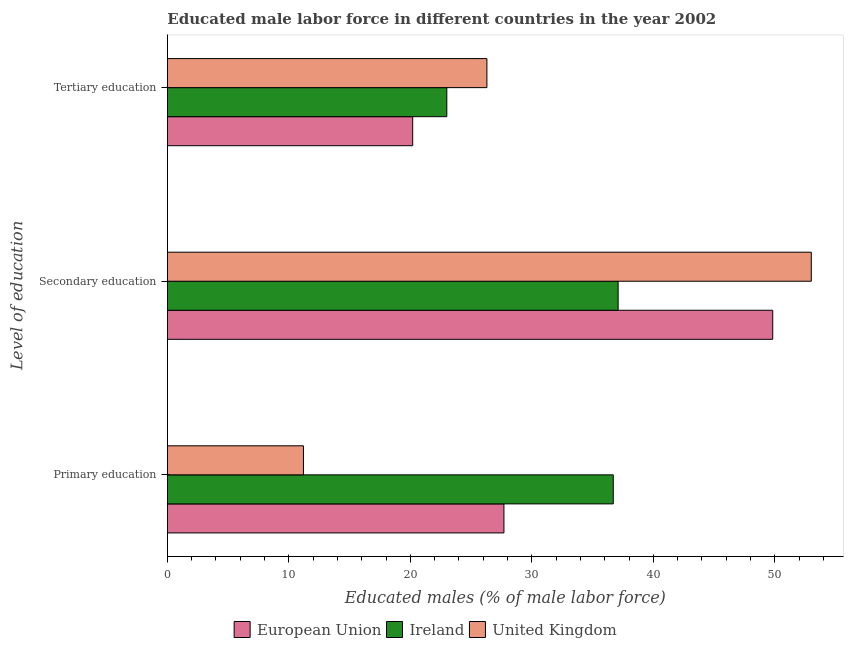Are the number of bars per tick equal to the number of legend labels?
Your response must be concise. Yes. How many bars are there on the 2nd tick from the top?
Your answer should be very brief. 3. What is the label of the 3rd group of bars from the top?
Give a very brief answer. Primary education. What is the percentage of male labor force who received tertiary education in Ireland?
Offer a terse response. 23. Across all countries, what is the maximum percentage of male labor force who received primary education?
Give a very brief answer. 36.7. Across all countries, what is the minimum percentage of male labor force who received primary education?
Provide a short and direct response. 11.2. In which country was the percentage of male labor force who received tertiary education maximum?
Give a very brief answer. United Kingdom. In which country was the percentage of male labor force who received secondary education minimum?
Offer a very short reply. Ireland. What is the total percentage of male labor force who received secondary education in the graph?
Make the answer very short. 139.93. What is the difference between the percentage of male labor force who received secondary education in Ireland and that in United Kingdom?
Make the answer very short. -15.9. What is the difference between the percentage of male labor force who received secondary education in European Union and the percentage of male labor force who received primary education in Ireland?
Offer a terse response. 13.13. What is the average percentage of male labor force who received secondary education per country?
Give a very brief answer. 46.64. What is the difference between the percentage of male labor force who received secondary education and percentage of male labor force who received primary education in United Kingdom?
Your response must be concise. 41.8. What is the ratio of the percentage of male labor force who received secondary education in European Union to that in Ireland?
Your response must be concise. 1.34. Is the percentage of male labor force who received primary education in Ireland less than that in European Union?
Make the answer very short. No. What is the difference between the highest and the second highest percentage of male labor force who received tertiary education?
Your response must be concise. 3.3. What is the difference between the highest and the lowest percentage of male labor force who received secondary education?
Provide a short and direct response. 15.9. Is the sum of the percentage of male labor force who received tertiary education in United Kingdom and Ireland greater than the maximum percentage of male labor force who received secondary education across all countries?
Your answer should be compact. No. What does the 1st bar from the top in Primary education represents?
Ensure brevity in your answer.  United Kingdom. How many countries are there in the graph?
Give a very brief answer. 3. Are the values on the major ticks of X-axis written in scientific E-notation?
Offer a very short reply. No. Does the graph contain grids?
Provide a succinct answer. No. Where does the legend appear in the graph?
Offer a very short reply. Bottom center. What is the title of the graph?
Your answer should be very brief. Educated male labor force in different countries in the year 2002. What is the label or title of the X-axis?
Offer a terse response. Educated males (% of male labor force). What is the label or title of the Y-axis?
Offer a very short reply. Level of education. What is the Educated males (% of male labor force) of European Union in Primary education?
Provide a short and direct response. 27.7. What is the Educated males (% of male labor force) in Ireland in Primary education?
Keep it short and to the point. 36.7. What is the Educated males (% of male labor force) in United Kingdom in Primary education?
Provide a short and direct response. 11.2. What is the Educated males (% of male labor force) in European Union in Secondary education?
Your answer should be very brief. 49.83. What is the Educated males (% of male labor force) of Ireland in Secondary education?
Offer a terse response. 37.1. What is the Educated males (% of male labor force) in United Kingdom in Secondary education?
Offer a very short reply. 53. What is the Educated males (% of male labor force) of European Union in Tertiary education?
Provide a succinct answer. 20.19. What is the Educated males (% of male labor force) in United Kingdom in Tertiary education?
Ensure brevity in your answer.  26.3. Across all Level of education, what is the maximum Educated males (% of male labor force) of European Union?
Your response must be concise. 49.83. Across all Level of education, what is the maximum Educated males (% of male labor force) of Ireland?
Make the answer very short. 37.1. Across all Level of education, what is the maximum Educated males (% of male labor force) of United Kingdom?
Provide a succinct answer. 53. Across all Level of education, what is the minimum Educated males (% of male labor force) in European Union?
Offer a terse response. 20.19. Across all Level of education, what is the minimum Educated males (% of male labor force) of Ireland?
Give a very brief answer. 23. Across all Level of education, what is the minimum Educated males (% of male labor force) in United Kingdom?
Ensure brevity in your answer.  11.2. What is the total Educated males (% of male labor force) in European Union in the graph?
Your response must be concise. 97.72. What is the total Educated males (% of male labor force) of Ireland in the graph?
Provide a short and direct response. 96.8. What is the total Educated males (% of male labor force) of United Kingdom in the graph?
Offer a very short reply. 90.5. What is the difference between the Educated males (% of male labor force) of European Union in Primary education and that in Secondary education?
Offer a terse response. -22.12. What is the difference between the Educated males (% of male labor force) of United Kingdom in Primary education and that in Secondary education?
Offer a terse response. -41.8. What is the difference between the Educated males (% of male labor force) in European Union in Primary education and that in Tertiary education?
Ensure brevity in your answer.  7.51. What is the difference between the Educated males (% of male labor force) in United Kingdom in Primary education and that in Tertiary education?
Provide a succinct answer. -15.1. What is the difference between the Educated males (% of male labor force) of European Union in Secondary education and that in Tertiary education?
Offer a terse response. 29.63. What is the difference between the Educated males (% of male labor force) in Ireland in Secondary education and that in Tertiary education?
Provide a short and direct response. 14.1. What is the difference between the Educated males (% of male labor force) of United Kingdom in Secondary education and that in Tertiary education?
Your response must be concise. 26.7. What is the difference between the Educated males (% of male labor force) of European Union in Primary education and the Educated males (% of male labor force) of Ireland in Secondary education?
Offer a very short reply. -9.4. What is the difference between the Educated males (% of male labor force) of European Union in Primary education and the Educated males (% of male labor force) of United Kingdom in Secondary education?
Offer a very short reply. -25.3. What is the difference between the Educated males (% of male labor force) of Ireland in Primary education and the Educated males (% of male labor force) of United Kingdom in Secondary education?
Provide a succinct answer. -16.3. What is the difference between the Educated males (% of male labor force) in European Union in Primary education and the Educated males (% of male labor force) in Ireland in Tertiary education?
Provide a short and direct response. 4.7. What is the difference between the Educated males (% of male labor force) in European Union in Primary education and the Educated males (% of male labor force) in United Kingdom in Tertiary education?
Provide a succinct answer. 1.4. What is the difference between the Educated males (% of male labor force) in European Union in Secondary education and the Educated males (% of male labor force) in Ireland in Tertiary education?
Keep it short and to the point. 26.83. What is the difference between the Educated males (% of male labor force) in European Union in Secondary education and the Educated males (% of male labor force) in United Kingdom in Tertiary education?
Ensure brevity in your answer.  23.53. What is the average Educated males (% of male labor force) in European Union per Level of education?
Make the answer very short. 32.57. What is the average Educated males (% of male labor force) of Ireland per Level of education?
Ensure brevity in your answer.  32.27. What is the average Educated males (% of male labor force) of United Kingdom per Level of education?
Give a very brief answer. 30.17. What is the difference between the Educated males (% of male labor force) of European Union and Educated males (% of male labor force) of Ireland in Primary education?
Keep it short and to the point. -9. What is the difference between the Educated males (% of male labor force) in European Union and Educated males (% of male labor force) in United Kingdom in Primary education?
Ensure brevity in your answer.  16.5. What is the difference between the Educated males (% of male labor force) in Ireland and Educated males (% of male labor force) in United Kingdom in Primary education?
Make the answer very short. 25.5. What is the difference between the Educated males (% of male labor force) of European Union and Educated males (% of male labor force) of Ireland in Secondary education?
Your response must be concise. 12.73. What is the difference between the Educated males (% of male labor force) of European Union and Educated males (% of male labor force) of United Kingdom in Secondary education?
Offer a terse response. -3.17. What is the difference between the Educated males (% of male labor force) in Ireland and Educated males (% of male labor force) in United Kingdom in Secondary education?
Your response must be concise. -15.9. What is the difference between the Educated males (% of male labor force) of European Union and Educated males (% of male labor force) of Ireland in Tertiary education?
Provide a short and direct response. -2.81. What is the difference between the Educated males (% of male labor force) of European Union and Educated males (% of male labor force) of United Kingdom in Tertiary education?
Give a very brief answer. -6.11. What is the ratio of the Educated males (% of male labor force) in European Union in Primary education to that in Secondary education?
Offer a terse response. 0.56. What is the ratio of the Educated males (% of male labor force) of United Kingdom in Primary education to that in Secondary education?
Your response must be concise. 0.21. What is the ratio of the Educated males (% of male labor force) in European Union in Primary education to that in Tertiary education?
Ensure brevity in your answer.  1.37. What is the ratio of the Educated males (% of male labor force) in Ireland in Primary education to that in Tertiary education?
Provide a short and direct response. 1.6. What is the ratio of the Educated males (% of male labor force) in United Kingdom in Primary education to that in Tertiary education?
Keep it short and to the point. 0.43. What is the ratio of the Educated males (% of male labor force) of European Union in Secondary education to that in Tertiary education?
Offer a very short reply. 2.47. What is the ratio of the Educated males (% of male labor force) of Ireland in Secondary education to that in Tertiary education?
Give a very brief answer. 1.61. What is the ratio of the Educated males (% of male labor force) in United Kingdom in Secondary education to that in Tertiary education?
Offer a terse response. 2.02. What is the difference between the highest and the second highest Educated males (% of male labor force) in European Union?
Make the answer very short. 22.12. What is the difference between the highest and the second highest Educated males (% of male labor force) of United Kingdom?
Your answer should be very brief. 26.7. What is the difference between the highest and the lowest Educated males (% of male labor force) in European Union?
Make the answer very short. 29.63. What is the difference between the highest and the lowest Educated males (% of male labor force) of United Kingdom?
Your answer should be very brief. 41.8. 